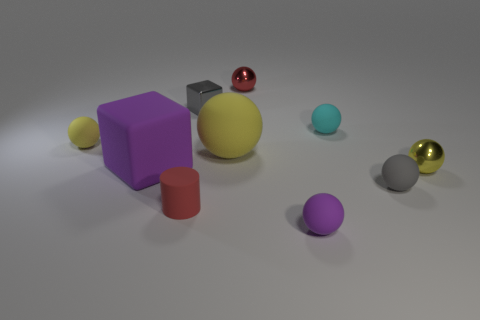How many yellow balls must be subtracted to get 1 yellow balls? 2 Subtract all purple cylinders. How many yellow spheres are left? 3 Subtract 4 balls. How many balls are left? 3 Subtract all cyan spheres. How many spheres are left? 6 Subtract all tiny red metal spheres. How many spheres are left? 6 Subtract all green balls. Subtract all cyan blocks. How many balls are left? 7 Subtract all blocks. How many objects are left? 8 Add 4 small purple matte spheres. How many small purple matte spheres exist? 5 Subtract 3 yellow spheres. How many objects are left? 7 Subtract all blue cylinders. Subtract all metallic spheres. How many objects are left? 8 